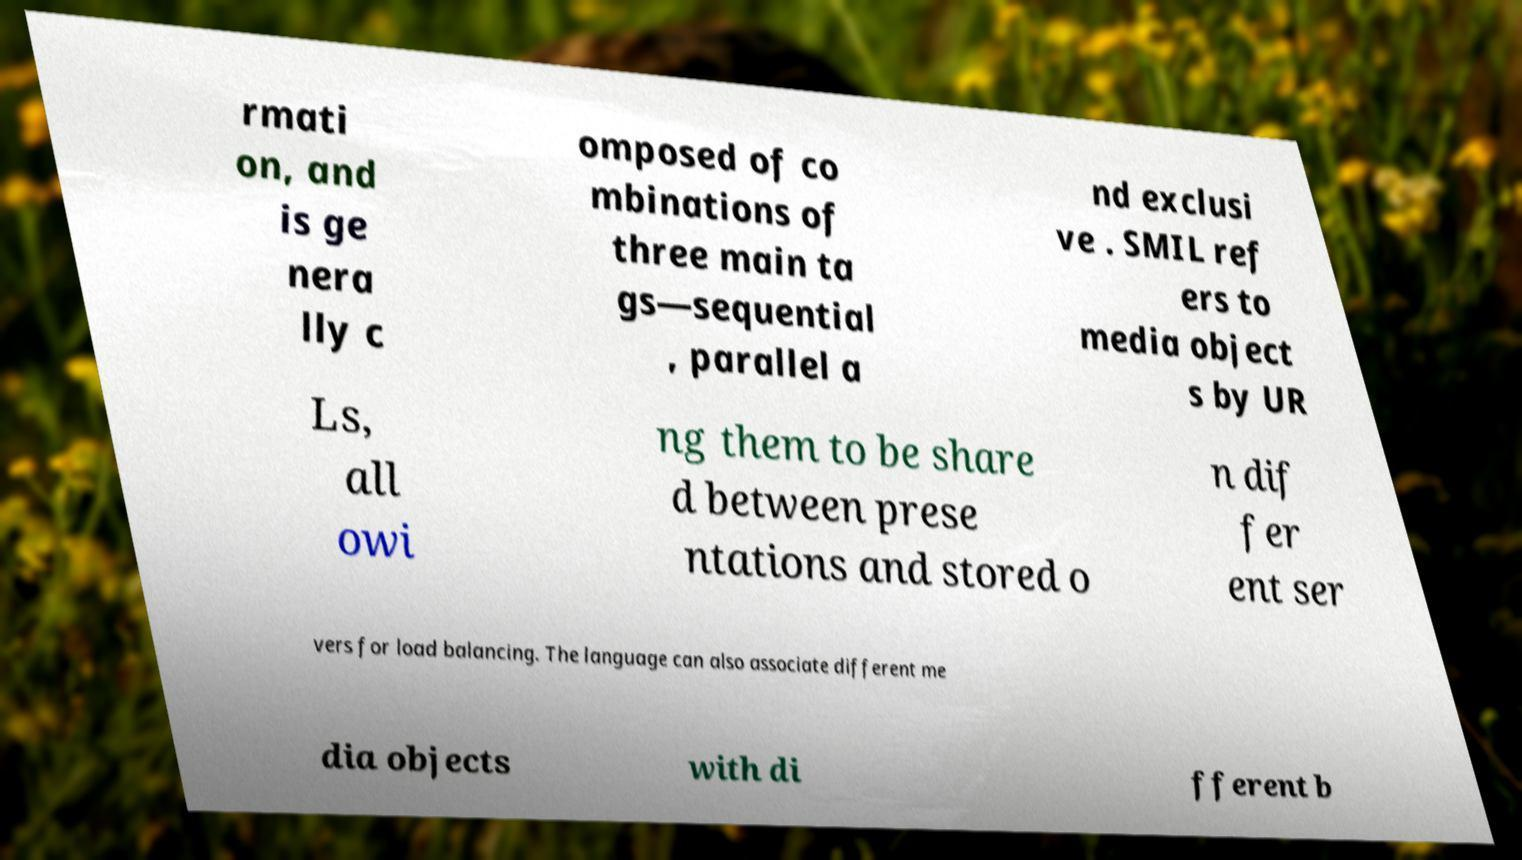Can you accurately transcribe the text from the provided image for me? rmati on, and is ge nera lly c omposed of co mbinations of three main ta gs—sequential , parallel a nd exclusi ve . SMIL ref ers to media object s by UR Ls, all owi ng them to be share d between prese ntations and stored o n dif fer ent ser vers for load balancing. The language can also associate different me dia objects with di fferent b 